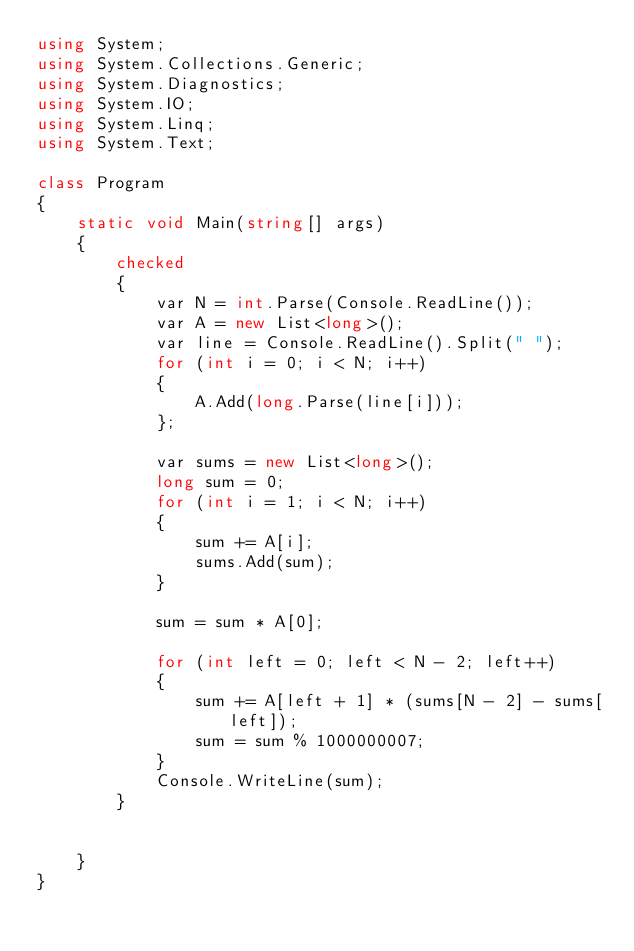Convert code to text. <code><loc_0><loc_0><loc_500><loc_500><_C#_>using System;
using System.Collections.Generic;
using System.Diagnostics;
using System.IO;
using System.Linq;
using System.Text;

class Program
{
    static void Main(string[] args)
    {
        checked
        {
            var N = int.Parse(Console.ReadLine());
            var A = new List<long>();
            var line = Console.ReadLine().Split(" ");
            for (int i = 0; i < N; i++)
            {
                A.Add(long.Parse(line[i]));
            };

            var sums = new List<long>();
            long sum = 0;
            for (int i = 1; i < N; i++)
            {
                sum += A[i];
                sums.Add(sum);
            }

            sum = sum * A[0];

            for (int left = 0; left < N - 2; left++)
            {
                sum += A[left + 1] * (sums[N - 2] - sums[left]);
                sum = sum % 1000000007;
            }
            Console.WriteLine(sum);
        }


    }
}</code> 